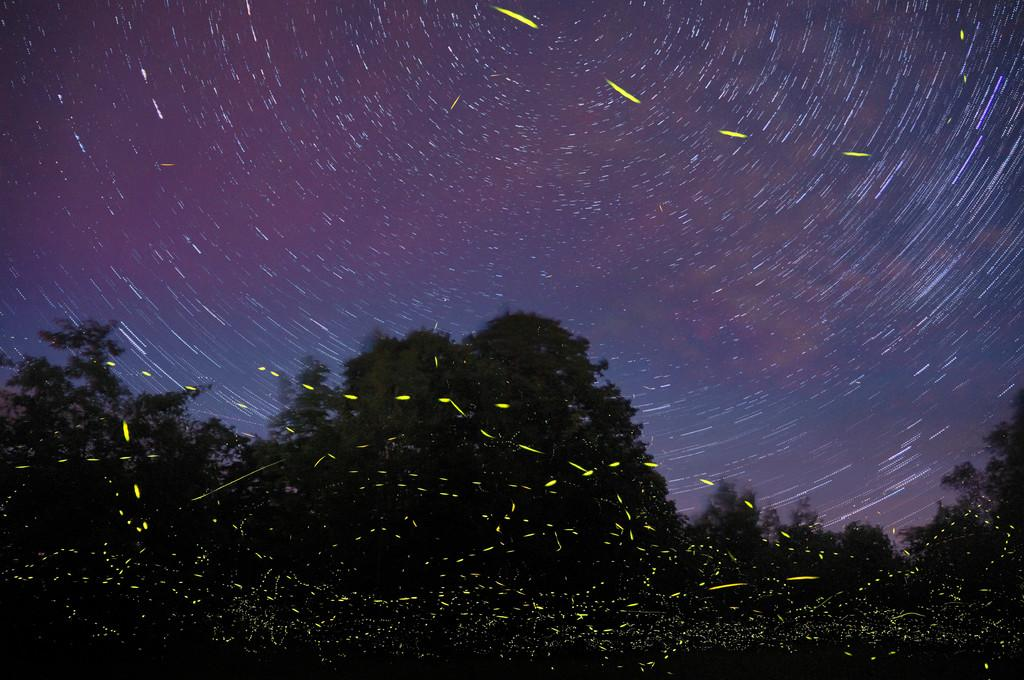What type of vegetation is present at the bottom of the image? There are trees at the bottom of the image. What type of popcorn is being sold by the company of farmers in the image? There is no reference to popcorn, a company, or farmers in the image, so it is not possible to answer that question. 